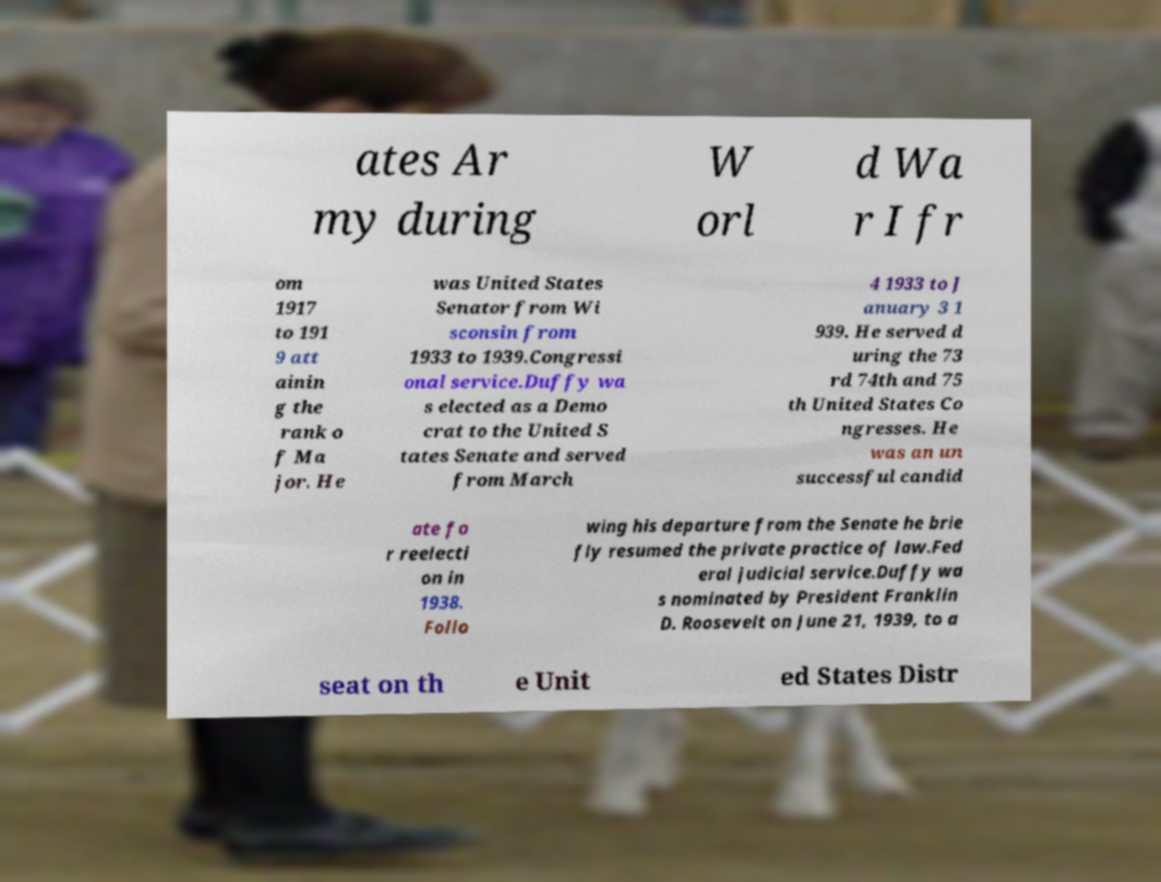Could you extract and type out the text from this image? ates Ar my during W orl d Wa r I fr om 1917 to 191 9 att ainin g the rank o f Ma jor. He was United States Senator from Wi sconsin from 1933 to 1939.Congressi onal service.Duffy wa s elected as a Demo crat to the United S tates Senate and served from March 4 1933 to J anuary 3 1 939. He served d uring the 73 rd 74th and 75 th United States Co ngresses. He was an un successful candid ate fo r reelecti on in 1938. Follo wing his departure from the Senate he brie fly resumed the private practice of law.Fed eral judicial service.Duffy wa s nominated by President Franklin D. Roosevelt on June 21, 1939, to a seat on th e Unit ed States Distr 